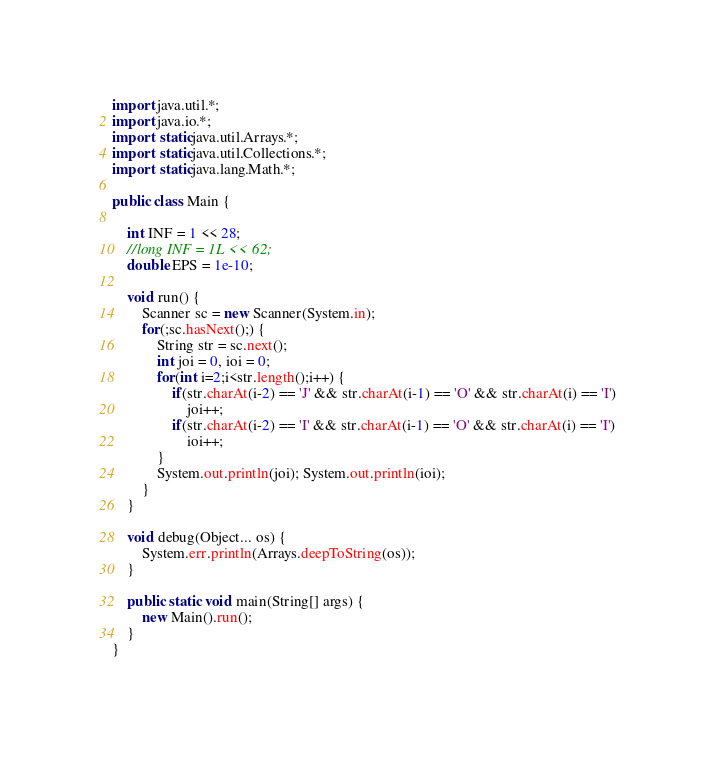Convert code to text. <code><loc_0><loc_0><loc_500><loc_500><_Java_>
import java.util.*;
import java.io.*;
import static java.util.Arrays.*;
import static java.util.Collections.*;
import static java.lang.Math.*;

public class Main {

	int INF = 1 << 28;
	//long INF = 1L << 62;
	double EPS = 1e-10;

	void run() {
		Scanner sc = new Scanner(System.in);
		for(;sc.hasNext();) {
			String str = sc.next();
			int joi = 0, ioi = 0;
			for(int i=2;i<str.length();i++) {
				if(str.charAt(i-2) == 'J' && str.charAt(i-1) == 'O' && str.charAt(i) == 'I')
					joi++;
				if(str.charAt(i-2) == 'I' && str.charAt(i-1) == 'O' && str.charAt(i) == 'I')
					ioi++;
			}
			System.out.println(joi); System.out.println(ioi);
		}
	}

	void debug(Object... os) {
		System.err.println(Arrays.deepToString(os));
	}

	public static void main(String[] args) {
		new Main().run();
	}
}</code> 